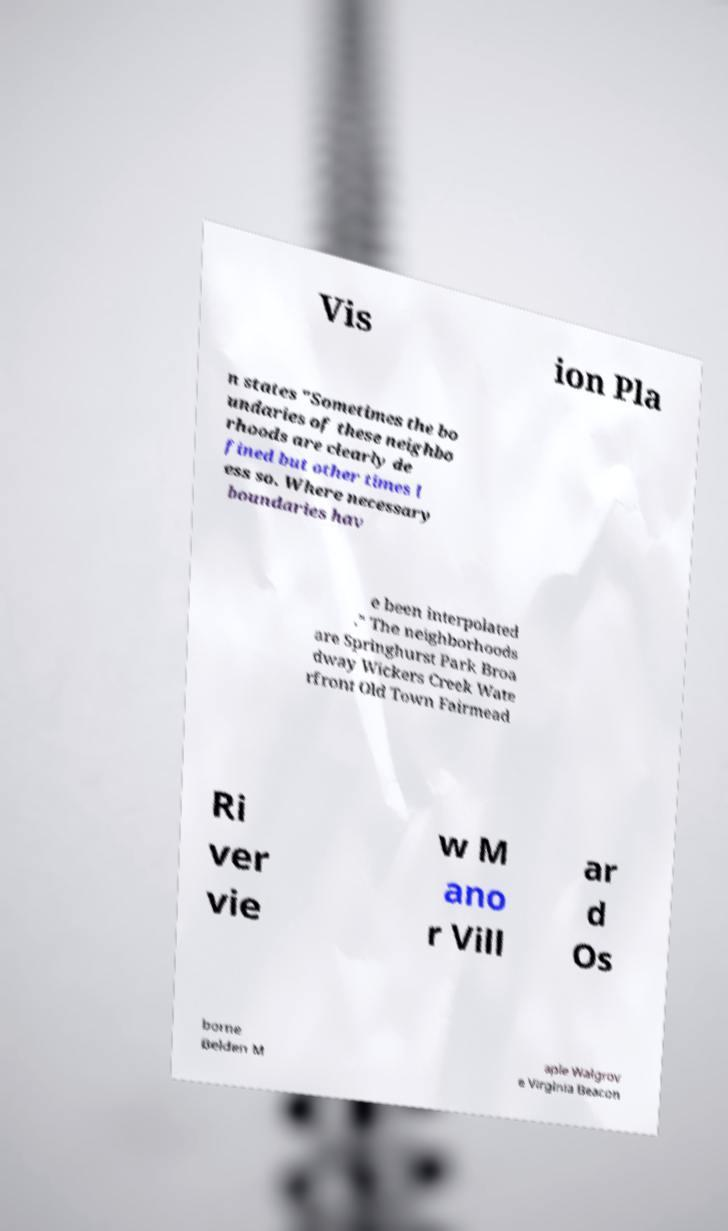What messages or text are displayed in this image? I need them in a readable, typed format. Vis ion Pla n states "Sometimes the bo undaries of these neighbo rhoods are clearly de fined but other times l ess so. Where necessary boundaries hav e been interpolated ." The neighborhoods are Springhurst Park Broa dway Wickers Creek Wate rfront Old Town Fairmead Ri ver vie w M ano r Vill ar d Os borne Belden M aple Walgrov e Virginia Beacon 